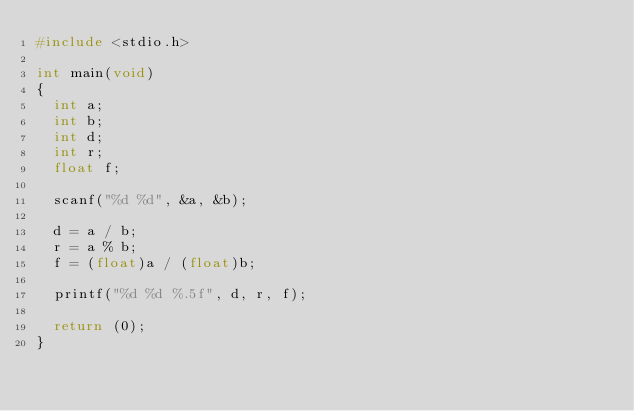Convert code to text. <code><loc_0><loc_0><loc_500><loc_500><_C_>#include <stdio.h>

int main(void)
{
	int a;
	int b;
	int d;
	int r;
	float f;
	
	scanf("%d %d", &a, &b);
	
	d = a / b;
	r = a % b;
	f = (float)a / (float)b;
	
	printf("%d %d %.5f", d, r, f);
	
	return (0);
}</code> 